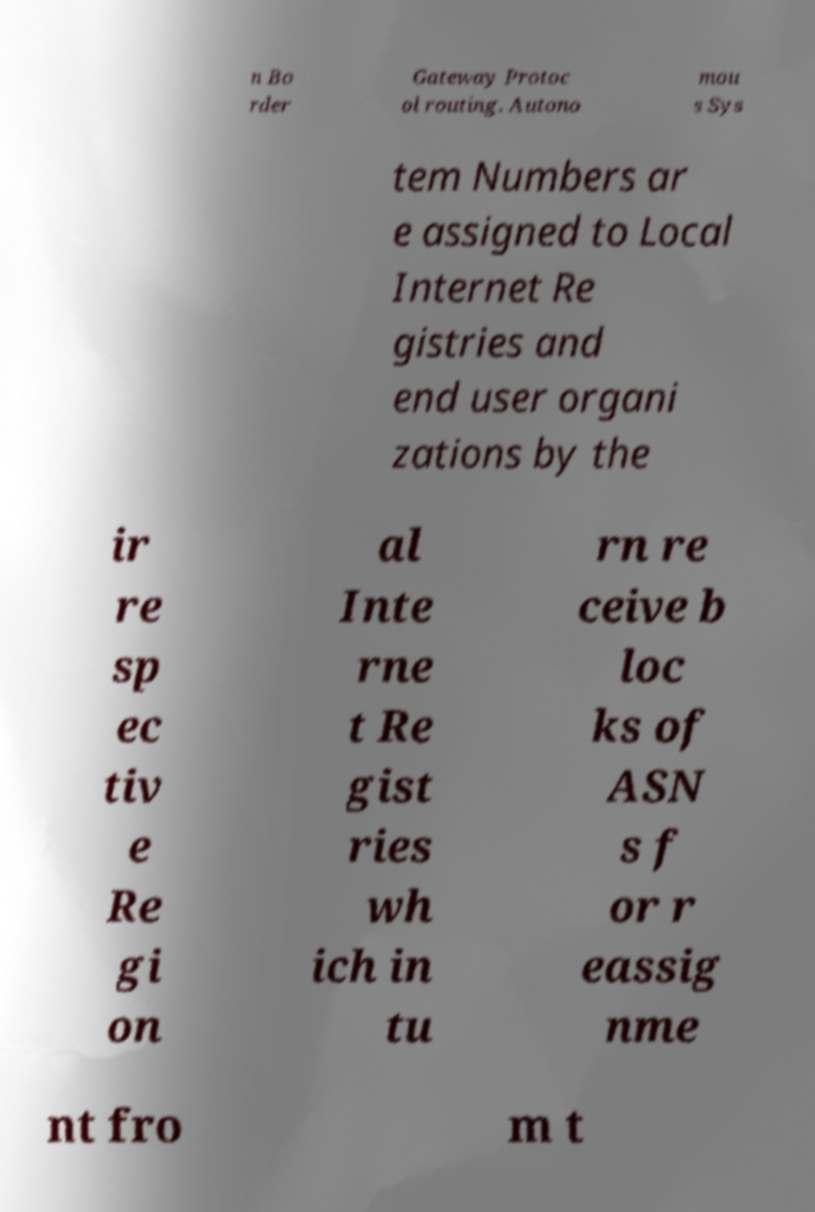Can you accurately transcribe the text from the provided image for me? n Bo rder Gateway Protoc ol routing. Autono mou s Sys tem Numbers ar e assigned to Local Internet Re gistries and end user organi zations by the ir re sp ec tiv e Re gi on al Inte rne t Re gist ries wh ich in tu rn re ceive b loc ks of ASN s f or r eassig nme nt fro m t 